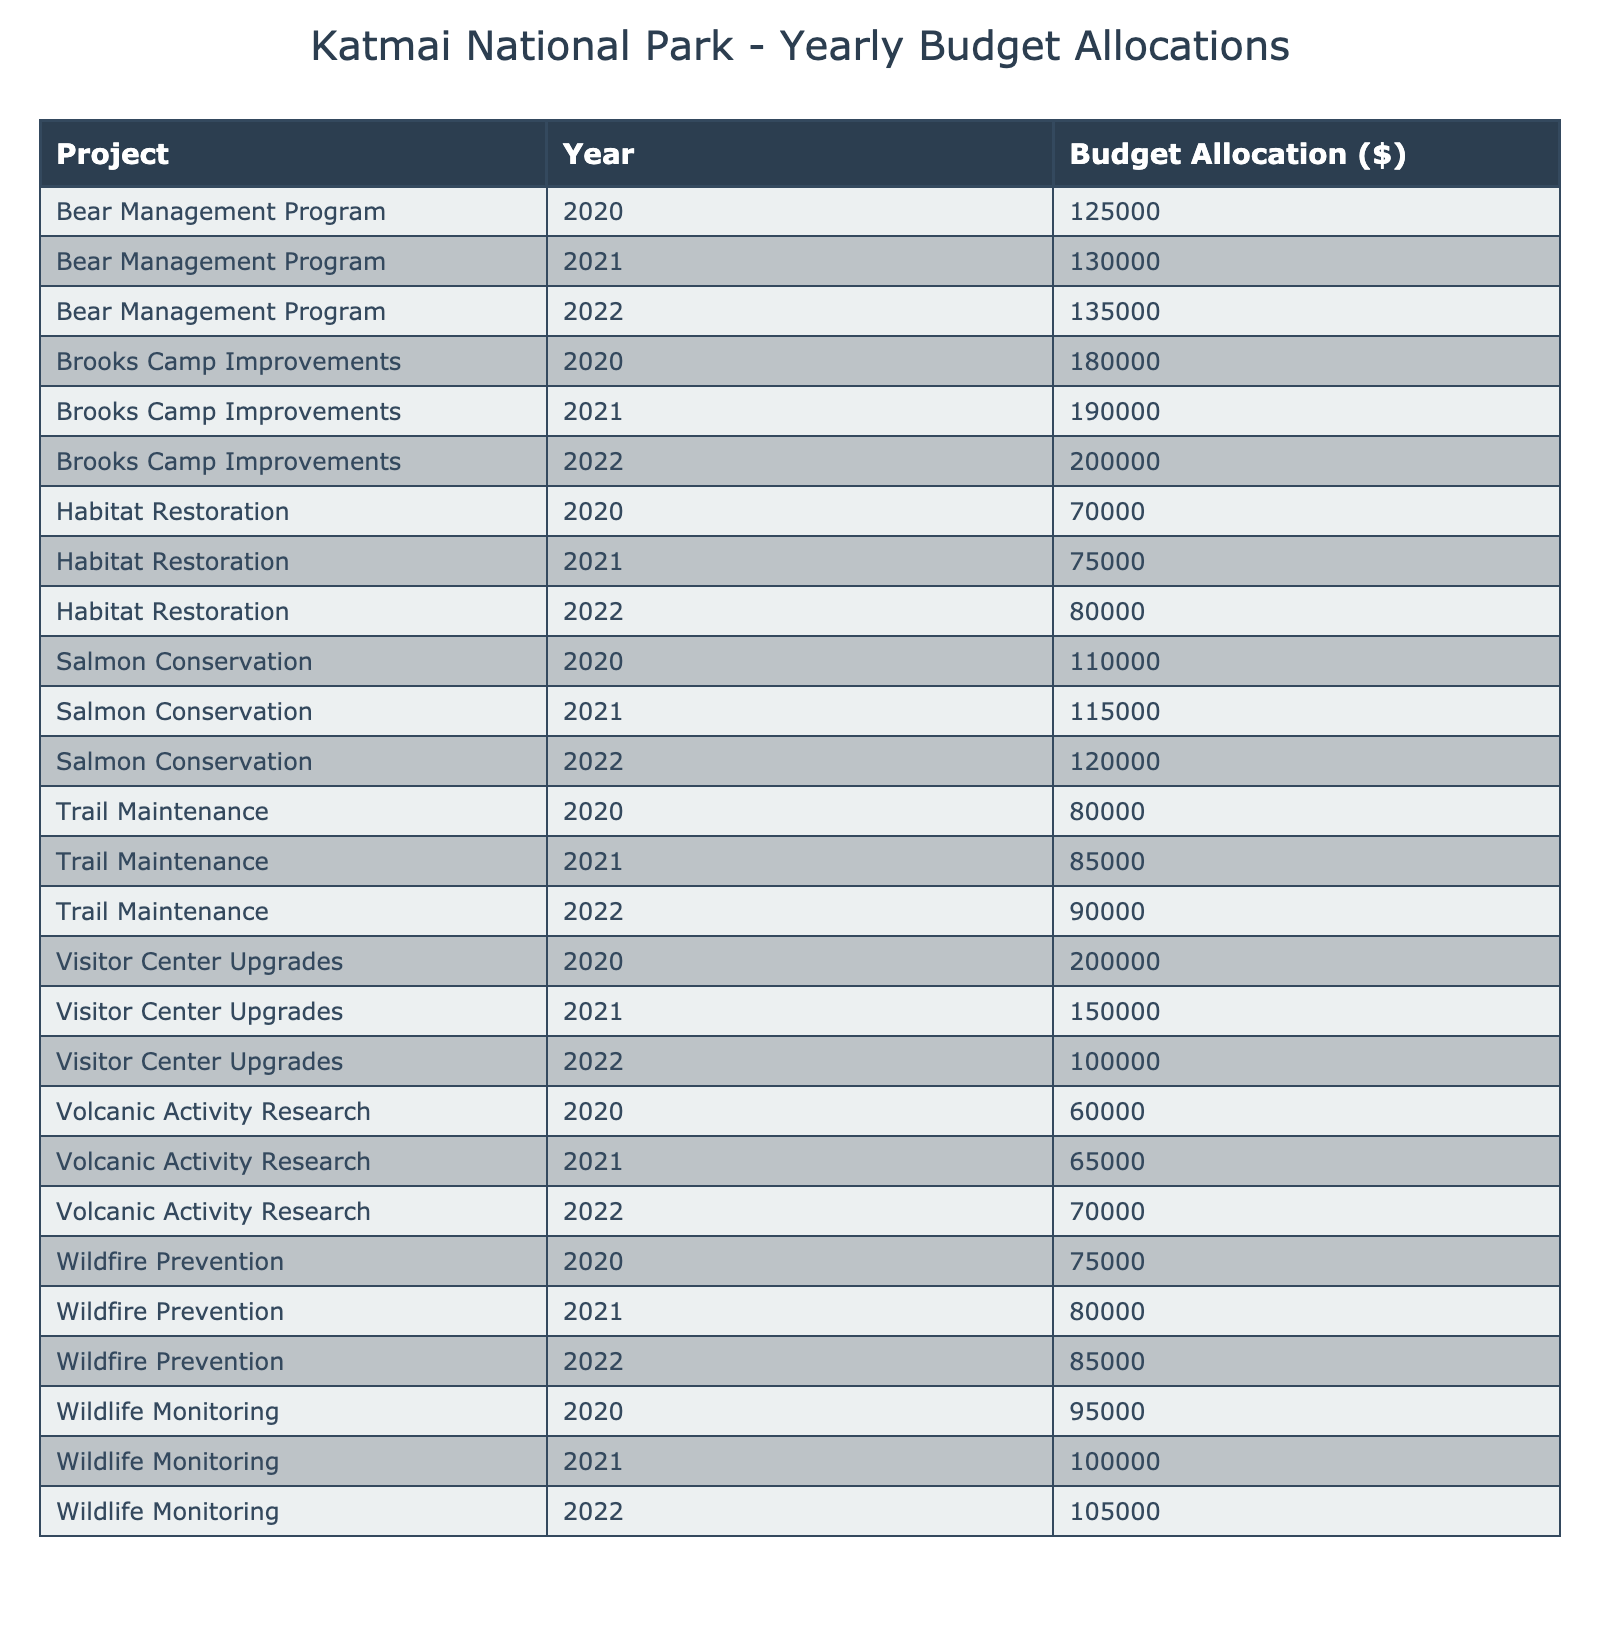What was the budget allocation for the Bear Management Program in 2021? The table shows that for the Bear Management Program, the budget allocation for the year 2021 is listed as $130,000.
Answer: $130,000 Which project had the highest budget allocation in 2020? By comparing the budget allocations of all projects for the year 2020, Brooks Camp Improvements had the highest allocation of $180,000.
Answer: Brooks Camp Improvements What is the total budget allocation for Trail Maintenance over the three years? The budget allocations for Trail Maintenance are $80,000 in 2020, $85,000 in 2021, and $90,000 in 2022. Summing these gives $80,000 + $85,000 + $90,000 = $255,000.
Answer: $255,000 Did the budget allocation for Wildlife Monitoring increase every year from 2020 to 2022? The budget allocations for Wildlife Monitoring were $95,000 in 2020, $100,000 in 2021, and $105,000 in 2022, which shows an increase each year.
Answer: Yes What is the average budget allocation for the Salmon Conservation project across the three years? The budget allocations for Salmon Conservation are $110,000 in 2020, $115,000 in 2021, and $120,000 in 2022. Adding these gives $110,000 + $115,000 + $120,000 = $345,000. Dividing by the three years gives an average of $345,000 / 3 = $115,000.
Answer: $115,000 What was the increase in budget allocation for the Visitor Center Upgrades from 2020 to 2022? The budget for Visitor Center Upgrades decreased from $200,000 in 2020 to $100,000 in 2022. The increase in this case is negative, so we calculate it as $100,000 - $200,000 = -$100,000.
Answer: -$100,000 Which project had the smallest budget in 2022, and what was the amount? By reviewing the budget allocations for 2022, Volcanic Activity Research had the smallest allocation of $70,000.
Answer: Volcanic Activity Research, $70,000 How much more was allocated to Brooks Camp Improvements in 2022 compared to Habitat Restoration in the same year? For Brooks Camp Improvements in 2022, the budget was $200,000, while for Habitat Restoration it was $80,000. The difference is $200,000 - $80,000 = $120,000.
Answer: $120,000 What percentage of the total budget for 2021 was allocated to the Wildfire Prevention project? In 2021, the total budget across all projects is $130,000 + $85,000 + $115,000 + $150,000 + $80,000 + $190,000 + $100,000 + $75,000 + $65,000 = $1,085,000. The Wildfire Prevention budget for that year is $80,000. The percentage is ($80,000 / $1,085,000) * 100 ≈ 7.37%.
Answer: Approximately 7.37% If we combine the budget allocations for both the Bear Management Program and Wildlife Monitoring from 2020 to 2022, what is the total? For the Bear Management Program, the allocations are $125,000 (2020), $130,000 (2021), and $135,000 (2022) giving a total of $390,000. For Wildlife Monitoring: $95,000 (2020), $100,000 (2021), $105,000 (2022) totaling $300,000. Adding both totals gives $390,000 + $300,000 = $690,000.
Answer: $690,000 